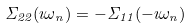<formula> <loc_0><loc_0><loc_500><loc_500>\Sigma _ { 2 2 } ( \imath \omega _ { n } ) = - \Sigma _ { 1 1 } ( - \imath \omega _ { n } )</formula> 